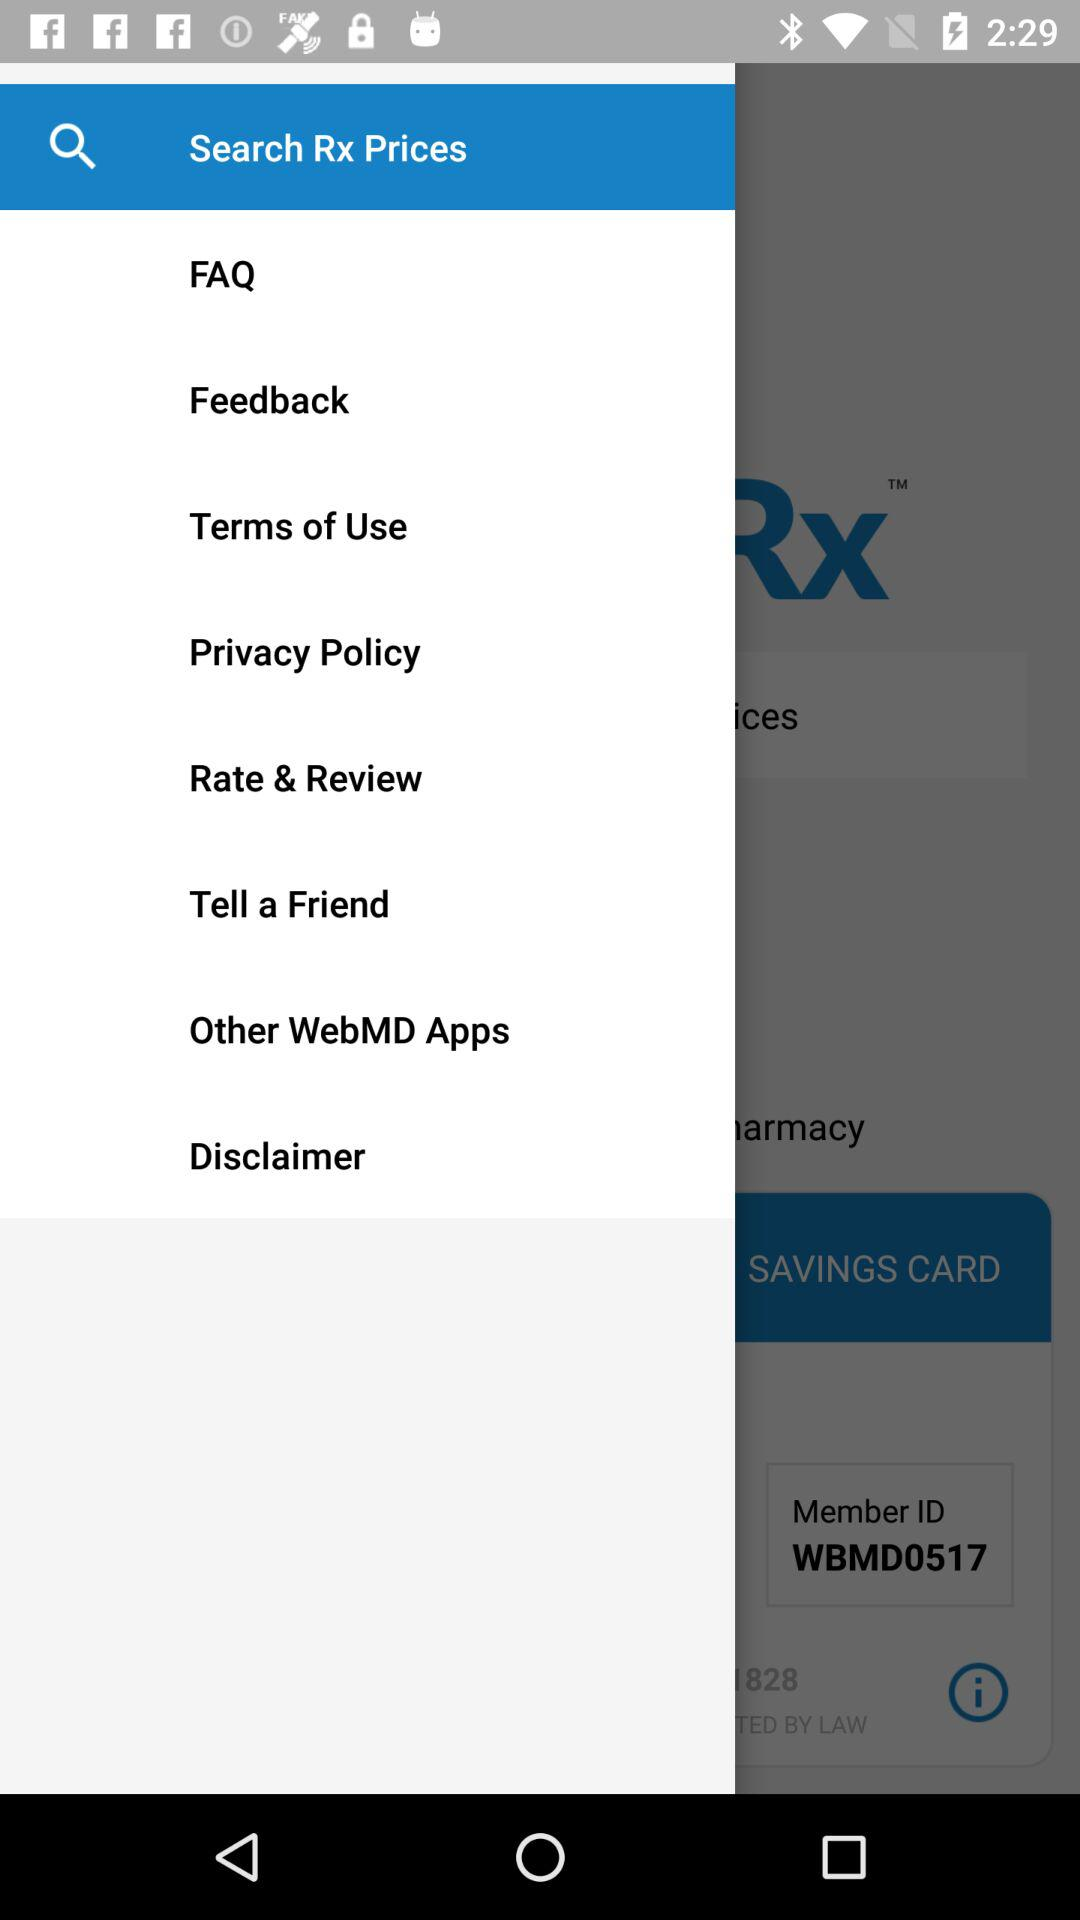What's the member ID? The member ID is "WBMD0517". 